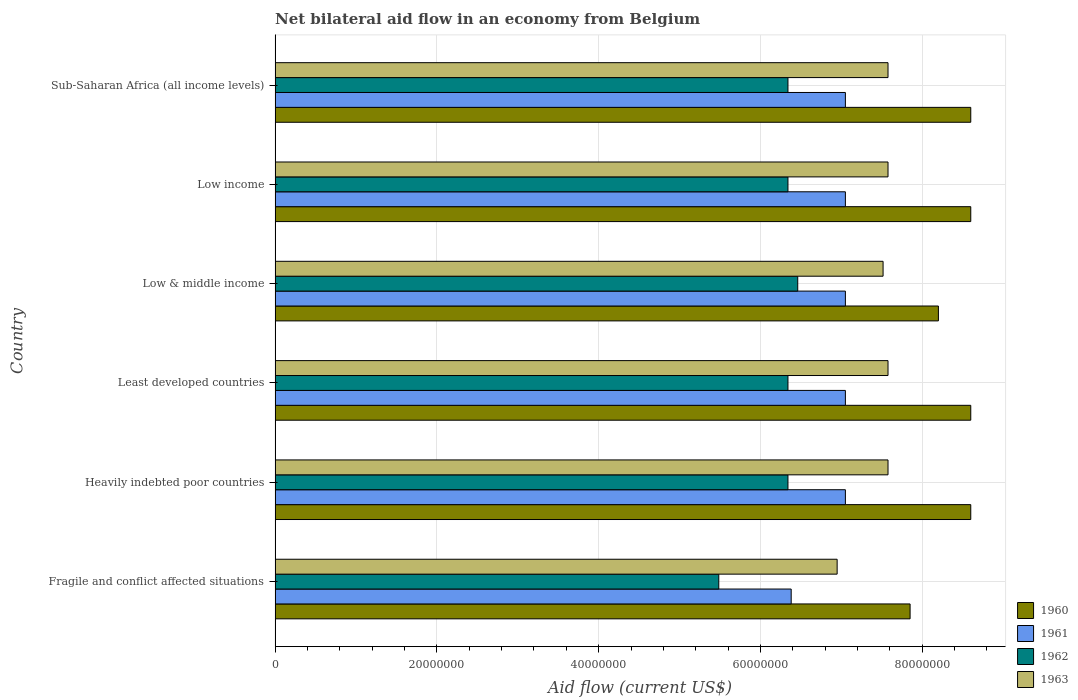How many different coloured bars are there?
Your answer should be very brief. 4. How many groups of bars are there?
Provide a short and direct response. 6. Are the number of bars on each tick of the Y-axis equal?
Your answer should be very brief. Yes. How many bars are there on the 3rd tick from the top?
Your answer should be compact. 4. How many bars are there on the 4th tick from the bottom?
Provide a short and direct response. 4. What is the label of the 2nd group of bars from the top?
Your answer should be compact. Low income. What is the net bilateral aid flow in 1961 in Least developed countries?
Your response must be concise. 7.05e+07. Across all countries, what is the maximum net bilateral aid flow in 1961?
Give a very brief answer. 7.05e+07. Across all countries, what is the minimum net bilateral aid flow in 1960?
Your answer should be very brief. 7.85e+07. In which country was the net bilateral aid flow in 1962 maximum?
Give a very brief answer. Low & middle income. In which country was the net bilateral aid flow in 1962 minimum?
Provide a short and direct response. Fragile and conflict affected situations. What is the total net bilateral aid flow in 1962 in the graph?
Ensure brevity in your answer.  3.73e+08. What is the difference between the net bilateral aid flow in 1961 in Heavily indebted poor countries and the net bilateral aid flow in 1962 in Fragile and conflict affected situations?
Offer a terse response. 1.56e+07. What is the average net bilateral aid flow in 1961 per country?
Your answer should be very brief. 6.94e+07. What is the difference between the net bilateral aid flow in 1961 and net bilateral aid flow in 1963 in Low & middle income?
Offer a terse response. -4.66e+06. What is the ratio of the net bilateral aid flow in 1961 in Least developed countries to that in Sub-Saharan Africa (all income levels)?
Your response must be concise. 1. What is the difference between the highest and the second highest net bilateral aid flow in 1961?
Give a very brief answer. 0. What is the difference between the highest and the lowest net bilateral aid flow in 1963?
Your answer should be compact. 6.29e+06. In how many countries, is the net bilateral aid flow in 1960 greater than the average net bilateral aid flow in 1960 taken over all countries?
Give a very brief answer. 4. Is the sum of the net bilateral aid flow in 1963 in Heavily indebted poor countries and Least developed countries greater than the maximum net bilateral aid flow in 1962 across all countries?
Offer a very short reply. Yes. Is it the case that in every country, the sum of the net bilateral aid flow in 1961 and net bilateral aid flow in 1963 is greater than the sum of net bilateral aid flow in 1962 and net bilateral aid flow in 1960?
Provide a succinct answer. No. What does the 4th bar from the top in Heavily indebted poor countries represents?
Ensure brevity in your answer.  1960. What does the 2nd bar from the bottom in Least developed countries represents?
Offer a very short reply. 1961. How many bars are there?
Ensure brevity in your answer.  24. How many countries are there in the graph?
Your response must be concise. 6. What is the difference between two consecutive major ticks on the X-axis?
Ensure brevity in your answer.  2.00e+07. Does the graph contain any zero values?
Your answer should be compact. No. Where does the legend appear in the graph?
Offer a very short reply. Bottom right. What is the title of the graph?
Give a very brief answer. Net bilateral aid flow in an economy from Belgium. Does "1968" appear as one of the legend labels in the graph?
Offer a very short reply. No. What is the label or title of the X-axis?
Your answer should be compact. Aid flow (current US$). What is the Aid flow (current US$) in 1960 in Fragile and conflict affected situations?
Keep it short and to the point. 7.85e+07. What is the Aid flow (current US$) of 1961 in Fragile and conflict affected situations?
Your answer should be very brief. 6.38e+07. What is the Aid flow (current US$) of 1962 in Fragile and conflict affected situations?
Give a very brief answer. 5.48e+07. What is the Aid flow (current US$) of 1963 in Fragile and conflict affected situations?
Ensure brevity in your answer.  6.95e+07. What is the Aid flow (current US$) in 1960 in Heavily indebted poor countries?
Provide a succinct answer. 8.60e+07. What is the Aid flow (current US$) of 1961 in Heavily indebted poor countries?
Provide a succinct answer. 7.05e+07. What is the Aid flow (current US$) in 1962 in Heavily indebted poor countries?
Make the answer very short. 6.34e+07. What is the Aid flow (current US$) in 1963 in Heavily indebted poor countries?
Provide a short and direct response. 7.58e+07. What is the Aid flow (current US$) of 1960 in Least developed countries?
Make the answer very short. 8.60e+07. What is the Aid flow (current US$) in 1961 in Least developed countries?
Keep it short and to the point. 7.05e+07. What is the Aid flow (current US$) in 1962 in Least developed countries?
Ensure brevity in your answer.  6.34e+07. What is the Aid flow (current US$) of 1963 in Least developed countries?
Your response must be concise. 7.58e+07. What is the Aid flow (current US$) in 1960 in Low & middle income?
Keep it short and to the point. 8.20e+07. What is the Aid flow (current US$) in 1961 in Low & middle income?
Provide a short and direct response. 7.05e+07. What is the Aid flow (current US$) of 1962 in Low & middle income?
Make the answer very short. 6.46e+07. What is the Aid flow (current US$) in 1963 in Low & middle income?
Provide a succinct answer. 7.52e+07. What is the Aid flow (current US$) of 1960 in Low income?
Your response must be concise. 8.60e+07. What is the Aid flow (current US$) in 1961 in Low income?
Your response must be concise. 7.05e+07. What is the Aid flow (current US$) of 1962 in Low income?
Keep it short and to the point. 6.34e+07. What is the Aid flow (current US$) of 1963 in Low income?
Provide a short and direct response. 7.58e+07. What is the Aid flow (current US$) in 1960 in Sub-Saharan Africa (all income levels)?
Offer a terse response. 8.60e+07. What is the Aid flow (current US$) of 1961 in Sub-Saharan Africa (all income levels)?
Keep it short and to the point. 7.05e+07. What is the Aid flow (current US$) in 1962 in Sub-Saharan Africa (all income levels)?
Ensure brevity in your answer.  6.34e+07. What is the Aid flow (current US$) in 1963 in Sub-Saharan Africa (all income levels)?
Keep it short and to the point. 7.58e+07. Across all countries, what is the maximum Aid flow (current US$) of 1960?
Provide a short and direct response. 8.60e+07. Across all countries, what is the maximum Aid flow (current US$) in 1961?
Ensure brevity in your answer.  7.05e+07. Across all countries, what is the maximum Aid flow (current US$) of 1962?
Give a very brief answer. 6.46e+07. Across all countries, what is the maximum Aid flow (current US$) of 1963?
Offer a terse response. 7.58e+07. Across all countries, what is the minimum Aid flow (current US$) of 1960?
Give a very brief answer. 7.85e+07. Across all countries, what is the minimum Aid flow (current US$) in 1961?
Provide a short and direct response. 6.38e+07. Across all countries, what is the minimum Aid flow (current US$) of 1962?
Your answer should be compact. 5.48e+07. Across all countries, what is the minimum Aid flow (current US$) of 1963?
Give a very brief answer. 6.95e+07. What is the total Aid flow (current US$) in 1960 in the graph?
Provide a succinct answer. 5.04e+08. What is the total Aid flow (current US$) in 1961 in the graph?
Your response must be concise. 4.16e+08. What is the total Aid flow (current US$) in 1962 in the graph?
Your answer should be compact. 3.73e+08. What is the total Aid flow (current US$) of 1963 in the graph?
Your response must be concise. 4.48e+08. What is the difference between the Aid flow (current US$) in 1960 in Fragile and conflict affected situations and that in Heavily indebted poor countries?
Ensure brevity in your answer.  -7.50e+06. What is the difference between the Aid flow (current US$) of 1961 in Fragile and conflict affected situations and that in Heavily indebted poor countries?
Ensure brevity in your answer.  -6.70e+06. What is the difference between the Aid flow (current US$) in 1962 in Fragile and conflict affected situations and that in Heavily indebted poor countries?
Provide a succinct answer. -8.55e+06. What is the difference between the Aid flow (current US$) of 1963 in Fragile and conflict affected situations and that in Heavily indebted poor countries?
Your answer should be very brief. -6.29e+06. What is the difference between the Aid flow (current US$) in 1960 in Fragile and conflict affected situations and that in Least developed countries?
Keep it short and to the point. -7.50e+06. What is the difference between the Aid flow (current US$) in 1961 in Fragile and conflict affected situations and that in Least developed countries?
Make the answer very short. -6.70e+06. What is the difference between the Aid flow (current US$) of 1962 in Fragile and conflict affected situations and that in Least developed countries?
Your answer should be very brief. -8.55e+06. What is the difference between the Aid flow (current US$) of 1963 in Fragile and conflict affected situations and that in Least developed countries?
Make the answer very short. -6.29e+06. What is the difference between the Aid flow (current US$) in 1960 in Fragile and conflict affected situations and that in Low & middle income?
Your answer should be very brief. -3.50e+06. What is the difference between the Aid flow (current US$) in 1961 in Fragile and conflict affected situations and that in Low & middle income?
Your response must be concise. -6.70e+06. What is the difference between the Aid flow (current US$) in 1962 in Fragile and conflict affected situations and that in Low & middle income?
Ensure brevity in your answer.  -9.76e+06. What is the difference between the Aid flow (current US$) of 1963 in Fragile and conflict affected situations and that in Low & middle income?
Your answer should be very brief. -5.68e+06. What is the difference between the Aid flow (current US$) in 1960 in Fragile and conflict affected situations and that in Low income?
Ensure brevity in your answer.  -7.50e+06. What is the difference between the Aid flow (current US$) of 1961 in Fragile and conflict affected situations and that in Low income?
Offer a very short reply. -6.70e+06. What is the difference between the Aid flow (current US$) in 1962 in Fragile and conflict affected situations and that in Low income?
Offer a very short reply. -8.55e+06. What is the difference between the Aid flow (current US$) of 1963 in Fragile and conflict affected situations and that in Low income?
Your response must be concise. -6.29e+06. What is the difference between the Aid flow (current US$) of 1960 in Fragile and conflict affected situations and that in Sub-Saharan Africa (all income levels)?
Your answer should be compact. -7.50e+06. What is the difference between the Aid flow (current US$) in 1961 in Fragile and conflict affected situations and that in Sub-Saharan Africa (all income levels)?
Your response must be concise. -6.70e+06. What is the difference between the Aid flow (current US$) of 1962 in Fragile and conflict affected situations and that in Sub-Saharan Africa (all income levels)?
Offer a very short reply. -8.55e+06. What is the difference between the Aid flow (current US$) of 1963 in Fragile and conflict affected situations and that in Sub-Saharan Africa (all income levels)?
Your answer should be compact. -6.29e+06. What is the difference between the Aid flow (current US$) in 1961 in Heavily indebted poor countries and that in Least developed countries?
Ensure brevity in your answer.  0. What is the difference between the Aid flow (current US$) of 1962 in Heavily indebted poor countries and that in Least developed countries?
Ensure brevity in your answer.  0. What is the difference between the Aid flow (current US$) in 1961 in Heavily indebted poor countries and that in Low & middle income?
Ensure brevity in your answer.  0. What is the difference between the Aid flow (current US$) in 1962 in Heavily indebted poor countries and that in Low & middle income?
Your response must be concise. -1.21e+06. What is the difference between the Aid flow (current US$) in 1961 in Heavily indebted poor countries and that in Low income?
Give a very brief answer. 0. What is the difference between the Aid flow (current US$) in 1960 in Heavily indebted poor countries and that in Sub-Saharan Africa (all income levels)?
Your answer should be compact. 0. What is the difference between the Aid flow (current US$) of 1961 in Least developed countries and that in Low & middle income?
Your response must be concise. 0. What is the difference between the Aid flow (current US$) in 1962 in Least developed countries and that in Low & middle income?
Offer a terse response. -1.21e+06. What is the difference between the Aid flow (current US$) in 1963 in Least developed countries and that in Low & middle income?
Give a very brief answer. 6.10e+05. What is the difference between the Aid flow (current US$) in 1960 in Least developed countries and that in Low income?
Keep it short and to the point. 0. What is the difference between the Aid flow (current US$) in 1963 in Least developed countries and that in Low income?
Keep it short and to the point. 0. What is the difference between the Aid flow (current US$) in 1962 in Low & middle income and that in Low income?
Provide a succinct answer. 1.21e+06. What is the difference between the Aid flow (current US$) in 1963 in Low & middle income and that in Low income?
Give a very brief answer. -6.10e+05. What is the difference between the Aid flow (current US$) in 1961 in Low & middle income and that in Sub-Saharan Africa (all income levels)?
Give a very brief answer. 0. What is the difference between the Aid flow (current US$) in 1962 in Low & middle income and that in Sub-Saharan Africa (all income levels)?
Your response must be concise. 1.21e+06. What is the difference between the Aid flow (current US$) in 1963 in Low & middle income and that in Sub-Saharan Africa (all income levels)?
Offer a terse response. -6.10e+05. What is the difference between the Aid flow (current US$) in 1960 in Low income and that in Sub-Saharan Africa (all income levels)?
Your response must be concise. 0. What is the difference between the Aid flow (current US$) in 1962 in Low income and that in Sub-Saharan Africa (all income levels)?
Keep it short and to the point. 0. What is the difference between the Aid flow (current US$) of 1960 in Fragile and conflict affected situations and the Aid flow (current US$) of 1962 in Heavily indebted poor countries?
Give a very brief answer. 1.51e+07. What is the difference between the Aid flow (current US$) of 1960 in Fragile and conflict affected situations and the Aid flow (current US$) of 1963 in Heavily indebted poor countries?
Ensure brevity in your answer.  2.73e+06. What is the difference between the Aid flow (current US$) in 1961 in Fragile and conflict affected situations and the Aid flow (current US$) in 1963 in Heavily indebted poor countries?
Provide a short and direct response. -1.20e+07. What is the difference between the Aid flow (current US$) in 1962 in Fragile and conflict affected situations and the Aid flow (current US$) in 1963 in Heavily indebted poor countries?
Offer a terse response. -2.09e+07. What is the difference between the Aid flow (current US$) of 1960 in Fragile and conflict affected situations and the Aid flow (current US$) of 1962 in Least developed countries?
Make the answer very short. 1.51e+07. What is the difference between the Aid flow (current US$) in 1960 in Fragile and conflict affected situations and the Aid flow (current US$) in 1963 in Least developed countries?
Make the answer very short. 2.73e+06. What is the difference between the Aid flow (current US$) of 1961 in Fragile and conflict affected situations and the Aid flow (current US$) of 1963 in Least developed countries?
Your answer should be very brief. -1.20e+07. What is the difference between the Aid flow (current US$) in 1962 in Fragile and conflict affected situations and the Aid flow (current US$) in 1963 in Least developed countries?
Make the answer very short. -2.09e+07. What is the difference between the Aid flow (current US$) of 1960 in Fragile and conflict affected situations and the Aid flow (current US$) of 1961 in Low & middle income?
Keep it short and to the point. 8.00e+06. What is the difference between the Aid flow (current US$) of 1960 in Fragile and conflict affected situations and the Aid flow (current US$) of 1962 in Low & middle income?
Offer a very short reply. 1.39e+07. What is the difference between the Aid flow (current US$) in 1960 in Fragile and conflict affected situations and the Aid flow (current US$) in 1963 in Low & middle income?
Offer a very short reply. 3.34e+06. What is the difference between the Aid flow (current US$) of 1961 in Fragile and conflict affected situations and the Aid flow (current US$) of 1962 in Low & middle income?
Your answer should be compact. -8.10e+05. What is the difference between the Aid flow (current US$) of 1961 in Fragile and conflict affected situations and the Aid flow (current US$) of 1963 in Low & middle income?
Offer a very short reply. -1.14e+07. What is the difference between the Aid flow (current US$) in 1962 in Fragile and conflict affected situations and the Aid flow (current US$) in 1963 in Low & middle income?
Provide a short and direct response. -2.03e+07. What is the difference between the Aid flow (current US$) in 1960 in Fragile and conflict affected situations and the Aid flow (current US$) in 1962 in Low income?
Your answer should be compact. 1.51e+07. What is the difference between the Aid flow (current US$) in 1960 in Fragile and conflict affected situations and the Aid flow (current US$) in 1963 in Low income?
Ensure brevity in your answer.  2.73e+06. What is the difference between the Aid flow (current US$) of 1961 in Fragile and conflict affected situations and the Aid flow (current US$) of 1963 in Low income?
Provide a succinct answer. -1.20e+07. What is the difference between the Aid flow (current US$) in 1962 in Fragile and conflict affected situations and the Aid flow (current US$) in 1963 in Low income?
Offer a very short reply. -2.09e+07. What is the difference between the Aid flow (current US$) in 1960 in Fragile and conflict affected situations and the Aid flow (current US$) in 1962 in Sub-Saharan Africa (all income levels)?
Provide a succinct answer. 1.51e+07. What is the difference between the Aid flow (current US$) in 1960 in Fragile and conflict affected situations and the Aid flow (current US$) in 1963 in Sub-Saharan Africa (all income levels)?
Provide a short and direct response. 2.73e+06. What is the difference between the Aid flow (current US$) of 1961 in Fragile and conflict affected situations and the Aid flow (current US$) of 1963 in Sub-Saharan Africa (all income levels)?
Provide a short and direct response. -1.20e+07. What is the difference between the Aid flow (current US$) in 1962 in Fragile and conflict affected situations and the Aid flow (current US$) in 1963 in Sub-Saharan Africa (all income levels)?
Keep it short and to the point. -2.09e+07. What is the difference between the Aid flow (current US$) of 1960 in Heavily indebted poor countries and the Aid flow (current US$) of 1961 in Least developed countries?
Provide a succinct answer. 1.55e+07. What is the difference between the Aid flow (current US$) in 1960 in Heavily indebted poor countries and the Aid flow (current US$) in 1962 in Least developed countries?
Your response must be concise. 2.26e+07. What is the difference between the Aid flow (current US$) of 1960 in Heavily indebted poor countries and the Aid flow (current US$) of 1963 in Least developed countries?
Offer a terse response. 1.02e+07. What is the difference between the Aid flow (current US$) in 1961 in Heavily indebted poor countries and the Aid flow (current US$) in 1962 in Least developed countries?
Provide a succinct answer. 7.10e+06. What is the difference between the Aid flow (current US$) of 1961 in Heavily indebted poor countries and the Aid flow (current US$) of 1963 in Least developed countries?
Keep it short and to the point. -5.27e+06. What is the difference between the Aid flow (current US$) of 1962 in Heavily indebted poor countries and the Aid flow (current US$) of 1963 in Least developed countries?
Provide a short and direct response. -1.24e+07. What is the difference between the Aid flow (current US$) in 1960 in Heavily indebted poor countries and the Aid flow (current US$) in 1961 in Low & middle income?
Offer a very short reply. 1.55e+07. What is the difference between the Aid flow (current US$) in 1960 in Heavily indebted poor countries and the Aid flow (current US$) in 1962 in Low & middle income?
Your response must be concise. 2.14e+07. What is the difference between the Aid flow (current US$) in 1960 in Heavily indebted poor countries and the Aid flow (current US$) in 1963 in Low & middle income?
Give a very brief answer. 1.08e+07. What is the difference between the Aid flow (current US$) of 1961 in Heavily indebted poor countries and the Aid flow (current US$) of 1962 in Low & middle income?
Ensure brevity in your answer.  5.89e+06. What is the difference between the Aid flow (current US$) of 1961 in Heavily indebted poor countries and the Aid flow (current US$) of 1963 in Low & middle income?
Ensure brevity in your answer.  -4.66e+06. What is the difference between the Aid flow (current US$) of 1962 in Heavily indebted poor countries and the Aid flow (current US$) of 1963 in Low & middle income?
Ensure brevity in your answer.  -1.18e+07. What is the difference between the Aid flow (current US$) in 1960 in Heavily indebted poor countries and the Aid flow (current US$) in 1961 in Low income?
Keep it short and to the point. 1.55e+07. What is the difference between the Aid flow (current US$) in 1960 in Heavily indebted poor countries and the Aid flow (current US$) in 1962 in Low income?
Give a very brief answer. 2.26e+07. What is the difference between the Aid flow (current US$) in 1960 in Heavily indebted poor countries and the Aid flow (current US$) in 1963 in Low income?
Offer a very short reply. 1.02e+07. What is the difference between the Aid flow (current US$) of 1961 in Heavily indebted poor countries and the Aid flow (current US$) of 1962 in Low income?
Make the answer very short. 7.10e+06. What is the difference between the Aid flow (current US$) in 1961 in Heavily indebted poor countries and the Aid flow (current US$) in 1963 in Low income?
Your response must be concise. -5.27e+06. What is the difference between the Aid flow (current US$) of 1962 in Heavily indebted poor countries and the Aid flow (current US$) of 1963 in Low income?
Keep it short and to the point. -1.24e+07. What is the difference between the Aid flow (current US$) of 1960 in Heavily indebted poor countries and the Aid flow (current US$) of 1961 in Sub-Saharan Africa (all income levels)?
Make the answer very short. 1.55e+07. What is the difference between the Aid flow (current US$) in 1960 in Heavily indebted poor countries and the Aid flow (current US$) in 1962 in Sub-Saharan Africa (all income levels)?
Your answer should be compact. 2.26e+07. What is the difference between the Aid flow (current US$) in 1960 in Heavily indebted poor countries and the Aid flow (current US$) in 1963 in Sub-Saharan Africa (all income levels)?
Your answer should be compact. 1.02e+07. What is the difference between the Aid flow (current US$) of 1961 in Heavily indebted poor countries and the Aid flow (current US$) of 1962 in Sub-Saharan Africa (all income levels)?
Keep it short and to the point. 7.10e+06. What is the difference between the Aid flow (current US$) of 1961 in Heavily indebted poor countries and the Aid flow (current US$) of 1963 in Sub-Saharan Africa (all income levels)?
Offer a very short reply. -5.27e+06. What is the difference between the Aid flow (current US$) of 1962 in Heavily indebted poor countries and the Aid flow (current US$) of 1963 in Sub-Saharan Africa (all income levels)?
Keep it short and to the point. -1.24e+07. What is the difference between the Aid flow (current US$) in 1960 in Least developed countries and the Aid flow (current US$) in 1961 in Low & middle income?
Provide a succinct answer. 1.55e+07. What is the difference between the Aid flow (current US$) in 1960 in Least developed countries and the Aid flow (current US$) in 1962 in Low & middle income?
Keep it short and to the point. 2.14e+07. What is the difference between the Aid flow (current US$) in 1960 in Least developed countries and the Aid flow (current US$) in 1963 in Low & middle income?
Give a very brief answer. 1.08e+07. What is the difference between the Aid flow (current US$) in 1961 in Least developed countries and the Aid flow (current US$) in 1962 in Low & middle income?
Provide a short and direct response. 5.89e+06. What is the difference between the Aid flow (current US$) in 1961 in Least developed countries and the Aid flow (current US$) in 1963 in Low & middle income?
Offer a very short reply. -4.66e+06. What is the difference between the Aid flow (current US$) in 1962 in Least developed countries and the Aid flow (current US$) in 1963 in Low & middle income?
Keep it short and to the point. -1.18e+07. What is the difference between the Aid flow (current US$) of 1960 in Least developed countries and the Aid flow (current US$) of 1961 in Low income?
Provide a short and direct response. 1.55e+07. What is the difference between the Aid flow (current US$) of 1960 in Least developed countries and the Aid flow (current US$) of 1962 in Low income?
Offer a very short reply. 2.26e+07. What is the difference between the Aid flow (current US$) in 1960 in Least developed countries and the Aid flow (current US$) in 1963 in Low income?
Your answer should be compact. 1.02e+07. What is the difference between the Aid flow (current US$) of 1961 in Least developed countries and the Aid flow (current US$) of 1962 in Low income?
Ensure brevity in your answer.  7.10e+06. What is the difference between the Aid flow (current US$) of 1961 in Least developed countries and the Aid flow (current US$) of 1963 in Low income?
Offer a very short reply. -5.27e+06. What is the difference between the Aid flow (current US$) in 1962 in Least developed countries and the Aid flow (current US$) in 1963 in Low income?
Your answer should be compact. -1.24e+07. What is the difference between the Aid flow (current US$) of 1960 in Least developed countries and the Aid flow (current US$) of 1961 in Sub-Saharan Africa (all income levels)?
Give a very brief answer. 1.55e+07. What is the difference between the Aid flow (current US$) of 1960 in Least developed countries and the Aid flow (current US$) of 1962 in Sub-Saharan Africa (all income levels)?
Ensure brevity in your answer.  2.26e+07. What is the difference between the Aid flow (current US$) in 1960 in Least developed countries and the Aid flow (current US$) in 1963 in Sub-Saharan Africa (all income levels)?
Offer a terse response. 1.02e+07. What is the difference between the Aid flow (current US$) in 1961 in Least developed countries and the Aid flow (current US$) in 1962 in Sub-Saharan Africa (all income levels)?
Provide a succinct answer. 7.10e+06. What is the difference between the Aid flow (current US$) of 1961 in Least developed countries and the Aid flow (current US$) of 1963 in Sub-Saharan Africa (all income levels)?
Provide a short and direct response. -5.27e+06. What is the difference between the Aid flow (current US$) in 1962 in Least developed countries and the Aid flow (current US$) in 1963 in Sub-Saharan Africa (all income levels)?
Your answer should be compact. -1.24e+07. What is the difference between the Aid flow (current US$) in 1960 in Low & middle income and the Aid flow (current US$) in 1961 in Low income?
Provide a succinct answer. 1.15e+07. What is the difference between the Aid flow (current US$) in 1960 in Low & middle income and the Aid flow (current US$) in 1962 in Low income?
Provide a succinct answer. 1.86e+07. What is the difference between the Aid flow (current US$) in 1960 in Low & middle income and the Aid flow (current US$) in 1963 in Low income?
Your answer should be compact. 6.23e+06. What is the difference between the Aid flow (current US$) in 1961 in Low & middle income and the Aid flow (current US$) in 1962 in Low income?
Provide a succinct answer. 7.10e+06. What is the difference between the Aid flow (current US$) in 1961 in Low & middle income and the Aid flow (current US$) in 1963 in Low income?
Provide a short and direct response. -5.27e+06. What is the difference between the Aid flow (current US$) of 1962 in Low & middle income and the Aid flow (current US$) of 1963 in Low income?
Provide a succinct answer. -1.12e+07. What is the difference between the Aid flow (current US$) of 1960 in Low & middle income and the Aid flow (current US$) of 1961 in Sub-Saharan Africa (all income levels)?
Your answer should be very brief. 1.15e+07. What is the difference between the Aid flow (current US$) in 1960 in Low & middle income and the Aid flow (current US$) in 1962 in Sub-Saharan Africa (all income levels)?
Offer a terse response. 1.86e+07. What is the difference between the Aid flow (current US$) in 1960 in Low & middle income and the Aid flow (current US$) in 1963 in Sub-Saharan Africa (all income levels)?
Provide a short and direct response. 6.23e+06. What is the difference between the Aid flow (current US$) of 1961 in Low & middle income and the Aid flow (current US$) of 1962 in Sub-Saharan Africa (all income levels)?
Your answer should be compact. 7.10e+06. What is the difference between the Aid flow (current US$) in 1961 in Low & middle income and the Aid flow (current US$) in 1963 in Sub-Saharan Africa (all income levels)?
Give a very brief answer. -5.27e+06. What is the difference between the Aid flow (current US$) of 1962 in Low & middle income and the Aid flow (current US$) of 1963 in Sub-Saharan Africa (all income levels)?
Give a very brief answer. -1.12e+07. What is the difference between the Aid flow (current US$) in 1960 in Low income and the Aid flow (current US$) in 1961 in Sub-Saharan Africa (all income levels)?
Your response must be concise. 1.55e+07. What is the difference between the Aid flow (current US$) of 1960 in Low income and the Aid flow (current US$) of 1962 in Sub-Saharan Africa (all income levels)?
Provide a succinct answer. 2.26e+07. What is the difference between the Aid flow (current US$) in 1960 in Low income and the Aid flow (current US$) in 1963 in Sub-Saharan Africa (all income levels)?
Offer a very short reply. 1.02e+07. What is the difference between the Aid flow (current US$) of 1961 in Low income and the Aid flow (current US$) of 1962 in Sub-Saharan Africa (all income levels)?
Offer a very short reply. 7.10e+06. What is the difference between the Aid flow (current US$) in 1961 in Low income and the Aid flow (current US$) in 1963 in Sub-Saharan Africa (all income levels)?
Provide a succinct answer. -5.27e+06. What is the difference between the Aid flow (current US$) in 1962 in Low income and the Aid flow (current US$) in 1963 in Sub-Saharan Africa (all income levels)?
Give a very brief answer. -1.24e+07. What is the average Aid flow (current US$) of 1960 per country?
Give a very brief answer. 8.41e+07. What is the average Aid flow (current US$) of 1961 per country?
Provide a succinct answer. 6.94e+07. What is the average Aid flow (current US$) of 1962 per country?
Provide a short and direct response. 6.22e+07. What is the average Aid flow (current US$) in 1963 per country?
Make the answer very short. 7.46e+07. What is the difference between the Aid flow (current US$) of 1960 and Aid flow (current US$) of 1961 in Fragile and conflict affected situations?
Provide a short and direct response. 1.47e+07. What is the difference between the Aid flow (current US$) in 1960 and Aid flow (current US$) in 1962 in Fragile and conflict affected situations?
Make the answer very short. 2.36e+07. What is the difference between the Aid flow (current US$) in 1960 and Aid flow (current US$) in 1963 in Fragile and conflict affected situations?
Your answer should be very brief. 9.02e+06. What is the difference between the Aid flow (current US$) in 1961 and Aid flow (current US$) in 1962 in Fragile and conflict affected situations?
Your response must be concise. 8.95e+06. What is the difference between the Aid flow (current US$) in 1961 and Aid flow (current US$) in 1963 in Fragile and conflict affected situations?
Keep it short and to the point. -5.68e+06. What is the difference between the Aid flow (current US$) in 1962 and Aid flow (current US$) in 1963 in Fragile and conflict affected situations?
Ensure brevity in your answer.  -1.46e+07. What is the difference between the Aid flow (current US$) in 1960 and Aid flow (current US$) in 1961 in Heavily indebted poor countries?
Your response must be concise. 1.55e+07. What is the difference between the Aid flow (current US$) in 1960 and Aid flow (current US$) in 1962 in Heavily indebted poor countries?
Make the answer very short. 2.26e+07. What is the difference between the Aid flow (current US$) of 1960 and Aid flow (current US$) of 1963 in Heavily indebted poor countries?
Your answer should be compact. 1.02e+07. What is the difference between the Aid flow (current US$) in 1961 and Aid flow (current US$) in 1962 in Heavily indebted poor countries?
Offer a very short reply. 7.10e+06. What is the difference between the Aid flow (current US$) in 1961 and Aid flow (current US$) in 1963 in Heavily indebted poor countries?
Ensure brevity in your answer.  -5.27e+06. What is the difference between the Aid flow (current US$) in 1962 and Aid flow (current US$) in 1963 in Heavily indebted poor countries?
Provide a succinct answer. -1.24e+07. What is the difference between the Aid flow (current US$) of 1960 and Aid flow (current US$) of 1961 in Least developed countries?
Keep it short and to the point. 1.55e+07. What is the difference between the Aid flow (current US$) in 1960 and Aid flow (current US$) in 1962 in Least developed countries?
Provide a succinct answer. 2.26e+07. What is the difference between the Aid flow (current US$) in 1960 and Aid flow (current US$) in 1963 in Least developed countries?
Your answer should be very brief. 1.02e+07. What is the difference between the Aid flow (current US$) of 1961 and Aid flow (current US$) of 1962 in Least developed countries?
Offer a very short reply. 7.10e+06. What is the difference between the Aid flow (current US$) of 1961 and Aid flow (current US$) of 1963 in Least developed countries?
Give a very brief answer. -5.27e+06. What is the difference between the Aid flow (current US$) in 1962 and Aid flow (current US$) in 1963 in Least developed countries?
Give a very brief answer. -1.24e+07. What is the difference between the Aid flow (current US$) in 1960 and Aid flow (current US$) in 1961 in Low & middle income?
Make the answer very short. 1.15e+07. What is the difference between the Aid flow (current US$) of 1960 and Aid flow (current US$) of 1962 in Low & middle income?
Provide a succinct answer. 1.74e+07. What is the difference between the Aid flow (current US$) of 1960 and Aid flow (current US$) of 1963 in Low & middle income?
Provide a short and direct response. 6.84e+06. What is the difference between the Aid flow (current US$) in 1961 and Aid flow (current US$) in 1962 in Low & middle income?
Your answer should be compact. 5.89e+06. What is the difference between the Aid flow (current US$) of 1961 and Aid flow (current US$) of 1963 in Low & middle income?
Ensure brevity in your answer.  -4.66e+06. What is the difference between the Aid flow (current US$) of 1962 and Aid flow (current US$) of 1963 in Low & middle income?
Your answer should be very brief. -1.06e+07. What is the difference between the Aid flow (current US$) of 1960 and Aid flow (current US$) of 1961 in Low income?
Your response must be concise. 1.55e+07. What is the difference between the Aid flow (current US$) of 1960 and Aid flow (current US$) of 1962 in Low income?
Your answer should be compact. 2.26e+07. What is the difference between the Aid flow (current US$) in 1960 and Aid flow (current US$) in 1963 in Low income?
Keep it short and to the point. 1.02e+07. What is the difference between the Aid flow (current US$) of 1961 and Aid flow (current US$) of 1962 in Low income?
Give a very brief answer. 7.10e+06. What is the difference between the Aid flow (current US$) of 1961 and Aid flow (current US$) of 1963 in Low income?
Offer a very short reply. -5.27e+06. What is the difference between the Aid flow (current US$) in 1962 and Aid flow (current US$) in 1963 in Low income?
Your response must be concise. -1.24e+07. What is the difference between the Aid flow (current US$) in 1960 and Aid flow (current US$) in 1961 in Sub-Saharan Africa (all income levels)?
Offer a terse response. 1.55e+07. What is the difference between the Aid flow (current US$) of 1960 and Aid flow (current US$) of 1962 in Sub-Saharan Africa (all income levels)?
Provide a succinct answer. 2.26e+07. What is the difference between the Aid flow (current US$) of 1960 and Aid flow (current US$) of 1963 in Sub-Saharan Africa (all income levels)?
Offer a very short reply. 1.02e+07. What is the difference between the Aid flow (current US$) in 1961 and Aid flow (current US$) in 1962 in Sub-Saharan Africa (all income levels)?
Your answer should be very brief. 7.10e+06. What is the difference between the Aid flow (current US$) of 1961 and Aid flow (current US$) of 1963 in Sub-Saharan Africa (all income levels)?
Your response must be concise. -5.27e+06. What is the difference between the Aid flow (current US$) of 1962 and Aid flow (current US$) of 1963 in Sub-Saharan Africa (all income levels)?
Your answer should be compact. -1.24e+07. What is the ratio of the Aid flow (current US$) in 1960 in Fragile and conflict affected situations to that in Heavily indebted poor countries?
Your response must be concise. 0.91. What is the ratio of the Aid flow (current US$) of 1961 in Fragile and conflict affected situations to that in Heavily indebted poor countries?
Your response must be concise. 0.91. What is the ratio of the Aid flow (current US$) in 1962 in Fragile and conflict affected situations to that in Heavily indebted poor countries?
Provide a short and direct response. 0.87. What is the ratio of the Aid flow (current US$) of 1963 in Fragile and conflict affected situations to that in Heavily indebted poor countries?
Provide a short and direct response. 0.92. What is the ratio of the Aid flow (current US$) of 1960 in Fragile and conflict affected situations to that in Least developed countries?
Make the answer very short. 0.91. What is the ratio of the Aid flow (current US$) in 1961 in Fragile and conflict affected situations to that in Least developed countries?
Your answer should be compact. 0.91. What is the ratio of the Aid flow (current US$) of 1962 in Fragile and conflict affected situations to that in Least developed countries?
Offer a very short reply. 0.87. What is the ratio of the Aid flow (current US$) of 1963 in Fragile and conflict affected situations to that in Least developed countries?
Keep it short and to the point. 0.92. What is the ratio of the Aid flow (current US$) in 1960 in Fragile and conflict affected situations to that in Low & middle income?
Provide a short and direct response. 0.96. What is the ratio of the Aid flow (current US$) of 1961 in Fragile and conflict affected situations to that in Low & middle income?
Keep it short and to the point. 0.91. What is the ratio of the Aid flow (current US$) in 1962 in Fragile and conflict affected situations to that in Low & middle income?
Offer a terse response. 0.85. What is the ratio of the Aid flow (current US$) of 1963 in Fragile and conflict affected situations to that in Low & middle income?
Your answer should be very brief. 0.92. What is the ratio of the Aid flow (current US$) of 1960 in Fragile and conflict affected situations to that in Low income?
Ensure brevity in your answer.  0.91. What is the ratio of the Aid flow (current US$) in 1961 in Fragile and conflict affected situations to that in Low income?
Your answer should be compact. 0.91. What is the ratio of the Aid flow (current US$) of 1962 in Fragile and conflict affected situations to that in Low income?
Provide a short and direct response. 0.87. What is the ratio of the Aid flow (current US$) in 1963 in Fragile and conflict affected situations to that in Low income?
Give a very brief answer. 0.92. What is the ratio of the Aid flow (current US$) of 1960 in Fragile and conflict affected situations to that in Sub-Saharan Africa (all income levels)?
Provide a short and direct response. 0.91. What is the ratio of the Aid flow (current US$) in 1961 in Fragile and conflict affected situations to that in Sub-Saharan Africa (all income levels)?
Offer a very short reply. 0.91. What is the ratio of the Aid flow (current US$) in 1962 in Fragile and conflict affected situations to that in Sub-Saharan Africa (all income levels)?
Your response must be concise. 0.87. What is the ratio of the Aid flow (current US$) of 1963 in Fragile and conflict affected situations to that in Sub-Saharan Africa (all income levels)?
Provide a succinct answer. 0.92. What is the ratio of the Aid flow (current US$) in 1960 in Heavily indebted poor countries to that in Least developed countries?
Your answer should be very brief. 1. What is the ratio of the Aid flow (current US$) of 1961 in Heavily indebted poor countries to that in Least developed countries?
Ensure brevity in your answer.  1. What is the ratio of the Aid flow (current US$) in 1960 in Heavily indebted poor countries to that in Low & middle income?
Offer a terse response. 1.05. What is the ratio of the Aid flow (current US$) of 1962 in Heavily indebted poor countries to that in Low & middle income?
Provide a short and direct response. 0.98. What is the ratio of the Aid flow (current US$) in 1960 in Heavily indebted poor countries to that in Low income?
Your response must be concise. 1. What is the ratio of the Aid flow (current US$) in 1963 in Heavily indebted poor countries to that in Sub-Saharan Africa (all income levels)?
Your response must be concise. 1. What is the ratio of the Aid flow (current US$) in 1960 in Least developed countries to that in Low & middle income?
Your answer should be very brief. 1.05. What is the ratio of the Aid flow (current US$) of 1962 in Least developed countries to that in Low & middle income?
Your answer should be compact. 0.98. What is the ratio of the Aid flow (current US$) in 1963 in Least developed countries to that in Low income?
Keep it short and to the point. 1. What is the ratio of the Aid flow (current US$) of 1960 in Least developed countries to that in Sub-Saharan Africa (all income levels)?
Keep it short and to the point. 1. What is the ratio of the Aid flow (current US$) of 1963 in Least developed countries to that in Sub-Saharan Africa (all income levels)?
Keep it short and to the point. 1. What is the ratio of the Aid flow (current US$) of 1960 in Low & middle income to that in Low income?
Make the answer very short. 0.95. What is the ratio of the Aid flow (current US$) in 1961 in Low & middle income to that in Low income?
Provide a short and direct response. 1. What is the ratio of the Aid flow (current US$) of 1962 in Low & middle income to that in Low income?
Your response must be concise. 1.02. What is the ratio of the Aid flow (current US$) in 1963 in Low & middle income to that in Low income?
Offer a terse response. 0.99. What is the ratio of the Aid flow (current US$) of 1960 in Low & middle income to that in Sub-Saharan Africa (all income levels)?
Make the answer very short. 0.95. What is the ratio of the Aid flow (current US$) of 1961 in Low & middle income to that in Sub-Saharan Africa (all income levels)?
Make the answer very short. 1. What is the ratio of the Aid flow (current US$) of 1962 in Low & middle income to that in Sub-Saharan Africa (all income levels)?
Your response must be concise. 1.02. What is the ratio of the Aid flow (current US$) of 1963 in Low & middle income to that in Sub-Saharan Africa (all income levels)?
Your answer should be very brief. 0.99. What is the ratio of the Aid flow (current US$) of 1960 in Low income to that in Sub-Saharan Africa (all income levels)?
Ensure brevity in your answer.  1. What is the ratio of the Aid flow (current US$) of 1961 in Low income to that in Sub-Saharan Africa (all income levels)?
Your answer should be compact. 1. What is the ratio of the Aid flow (current US$) of 1962 in Low income to that in Sub-Saharan Africa (all income levels)?
Provide a short and direct response. 1. What is the ratio of the Aid flow (current US$) in 1963 in Low income to that in Sub-Saharan Africa (all income levels)?
Offer a very short reply. 1. What is the difference between the highest and the second highest Aid flow (current US$) in 1960?
Provide a succinct answer. 0. What is the difference between the highest and the second highest Aid flow (current US$) in 1961?
Your response must be concise. 0. What is the difference between the highest and the second highest Aid flow (current US$) of 1962?
Your answer should be compact. 1.21e+06. What is the difference between the highest and the second highest Aid flow (current US$) of 1963?
Provide a short and direct response. 0. What is the difference between the highest and the lowest Aid flow (current US$) in 1960?
Ensure brevity in your answer.  7.50e+06. What is the difference between the highest and the lowest Aid flow (current US$) of 1961?
Keep it short and to the point. 6.70e+06. What is the difference between the highest and the lowest Aid flow (current US$) in 1962?
Your answer should be compact. 9.76e+06. What is the difference between the highest and the lowest Aid flow (current US$) in 1963?
Ensure brevity in your answer.  6.29e+06. 